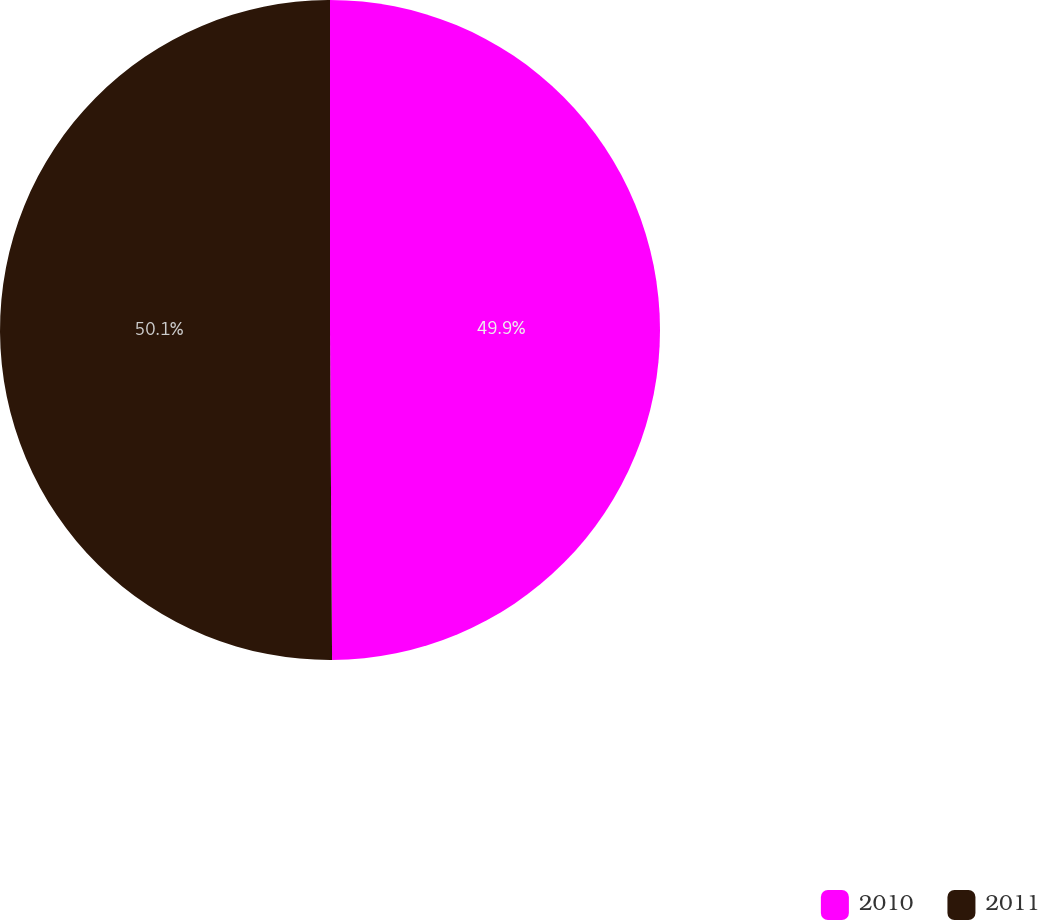Convert chart. <chart><loc_0><loc_0><loc_500><loc_500><pie_chart><fcel>2010<fcel>2011<nl><fcel>49.9%<fcel>50.1%<nl></chart> 